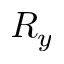<formula> <loc_0><loc_0><loc_500><loc_500>R _ { y }</formula> 